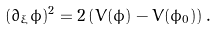Convert formula to latex. <formula><loc_0><loc_0><loc_500><loc_500>( \partial _ { \xi } \phi ) ^ { 2 } = 2 \left ( V ( \phi ) - V ( \phi _ { 0 } ) \right ) .</formula> 